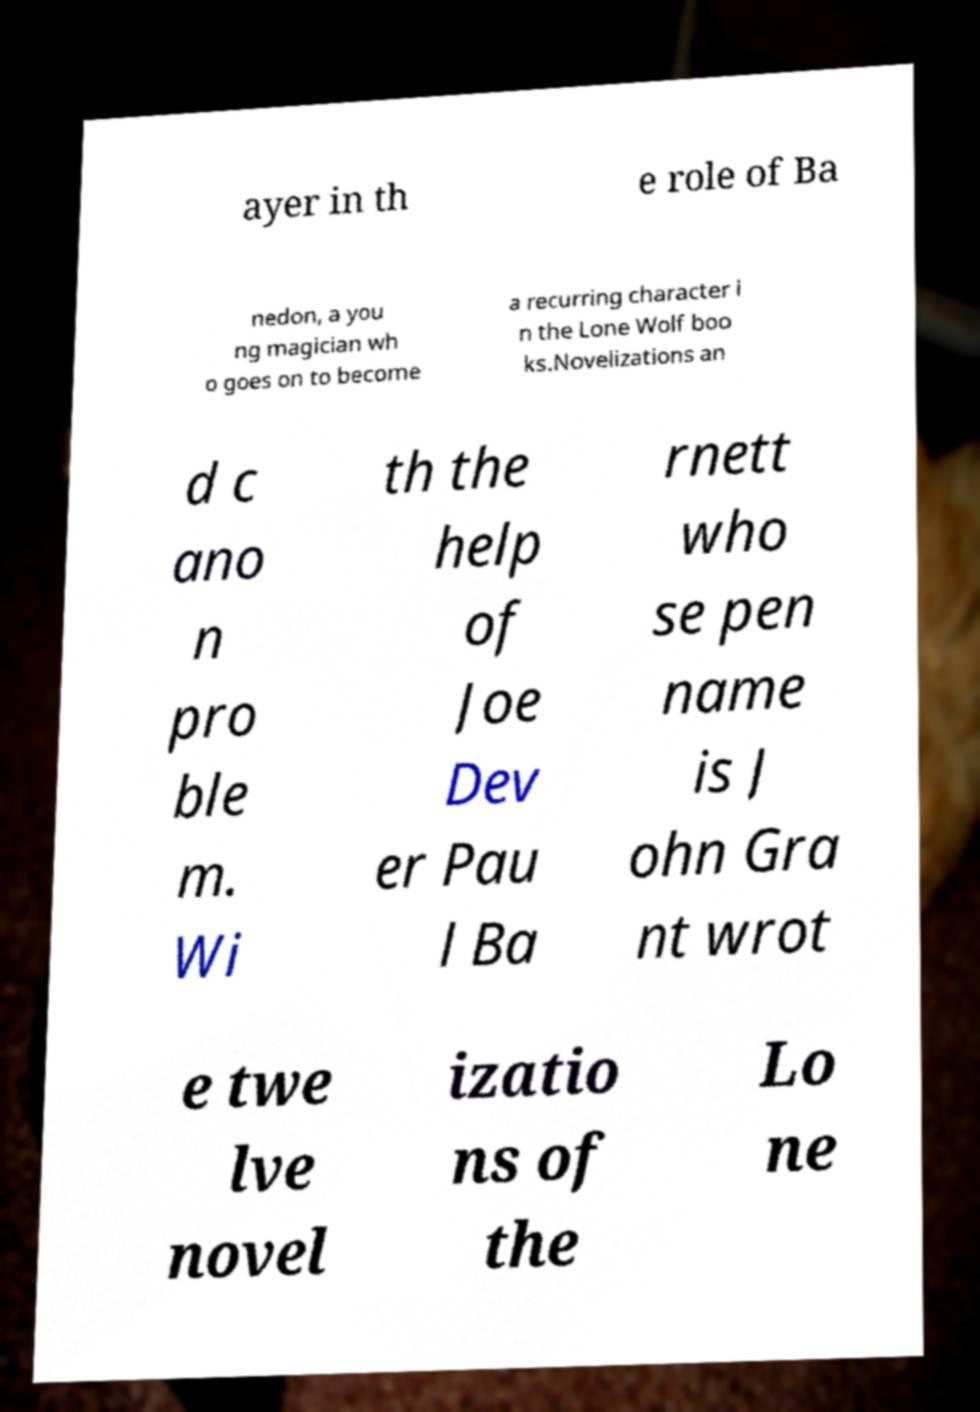I need the written content from this picture converted into text. Can you do that? ayer in th e role of Ba nedon, a you ng magician wh o goes on to become a recurring character i n the Lone Wolf boo ks.Novelizations an d c ano n pro ble m. Wi th the help of Joe Dev er Pau l Ba rnett who se pen name is J ohn Gra nt wrot e twe lve novel izatio ns of the Lo ne 